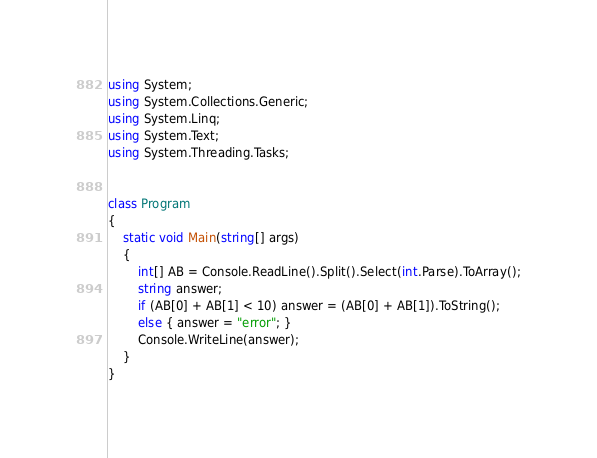Convert code to text. <code><loc_0><loc_0><loc_500><loc_500><_C#_>using System;
using System.Collections.Generic;
using System.Linq;
using System.Text;
using System.Threading.Tasks;


class Program
{
    static void Main(string[] args)
    {
        int[] AB = Console.ReadLine().Split().Select(int.Parse).ToArray();
        string answer;
        if (AB[0] + AB[1] < 10) answer = (AB[0] + AB[1]).ToString();
        else { answer = "error"; }
        Console.WriteLine(answer);
    }
}</code> 